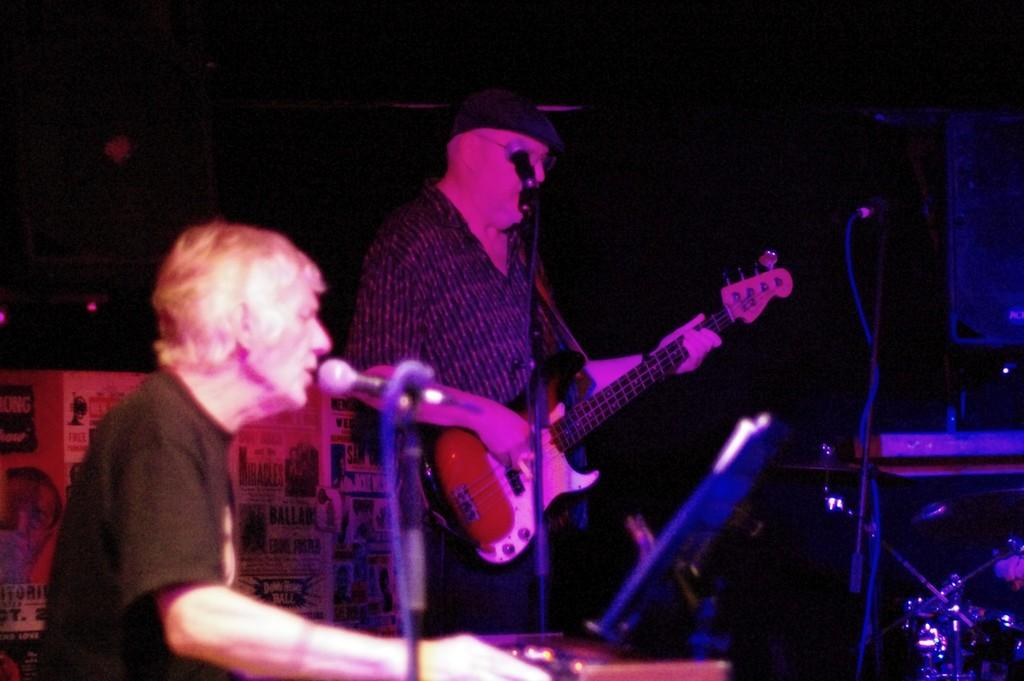How many people are in the image? There are two people in the image. What is the man doing in the image? The man is playing a guitar. What objects are present for amplifying sound in the image? There are microphones with stands in the image. What type of object is present that is related to music? There is at least one musical instrument in the image. What can be seen in the image that is not related to music or sound? There is a device in the image. What is the color of the background in the image? The background of the image is dark. What is hanging in the background of the image? There is a banner in the background of the image. Can you tell me how the bear is enjoying the taste of the guitar in the image? There is no bear present in the image, and the guitar is not being tasted. 